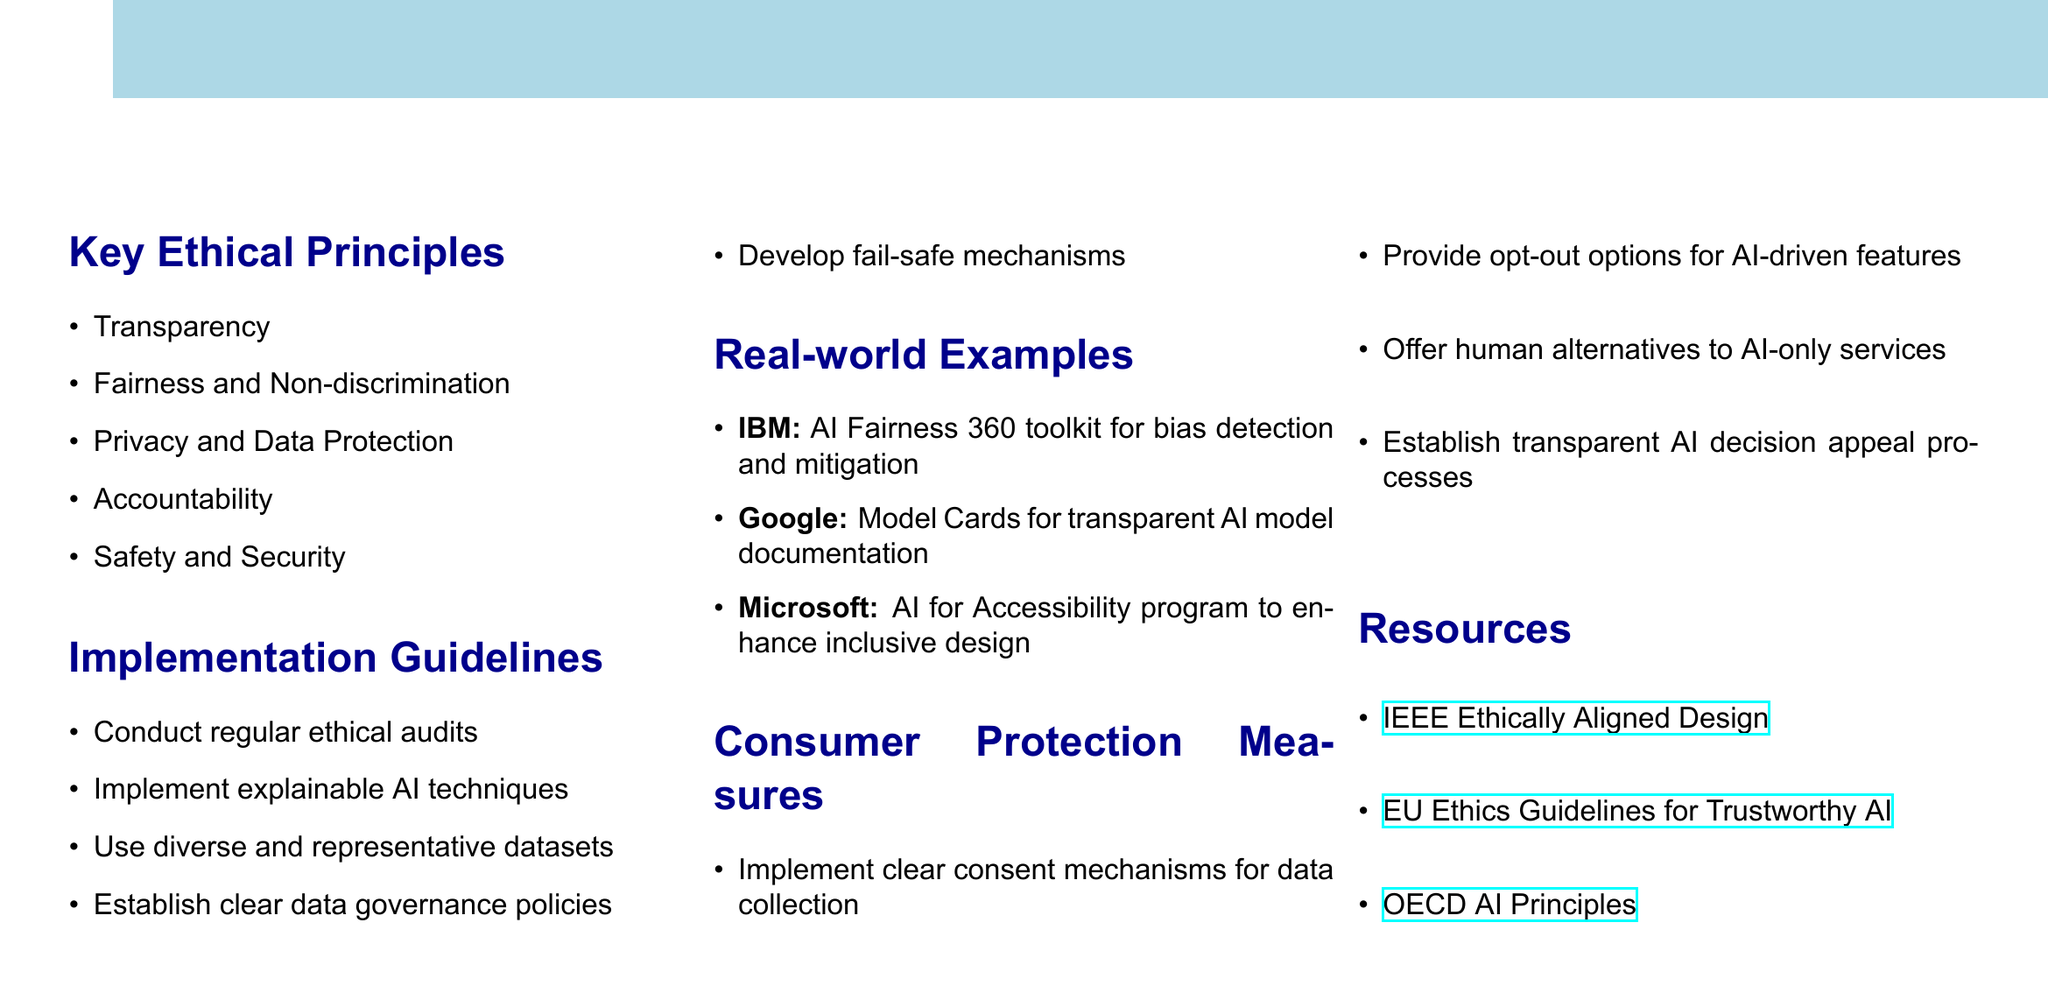What are the key ethical principles? The document lists five key ethical principles in AI ethics, which are mentioned in the "Key Ethical Principles" section.
Answer: Transparency, Fairness and Non-discrimination, Privacy and Data Protection, Accountability, Safety and Security What is the purpose of the AI Fairness 360 toolkit? The document provides a real-world example and mentions that IBM's toolkit is used for bias detection and mitigation under the "Real-world Examples" section.
Answer: Bias detection and mitigation How many consumer protection measures are mentioned? The section titled "Consumer Protection Measures" includes a specific count of measures that promote consumer rights in AI.
Answer: Four What organization provides the "Ethics Guidelines for Trustworthy AI"? The document includes a resource that is attributed to a specificorganization, which is mentioned in the "Resources" section.
Answer: EU What guideline suggests using diverse datasets? The implementation guideline that mentions representing various groups is found in the "Implementation Guidelines" section.
Answer: Use diverse and representative datasets How many real-world examples are provided? The "Real-world Examples" section lists three specific cases that illustrate ethical AI practices.
Answer: Three What should developers implement for data collection? The document specifies a consumer protection measure regarding how developers should handle data collection, which is found in the pertinent section.
Answer: Clear consent mechanisms What is an example of an accessible AI program? The example given under the "Real-world Examples" highlights a specific Microsoft program that aims to improve accessibility in AI design.
Answer: AI for Accessibility What is the main focus of the document? The title suggests that the document addresses specific guidelines and practices related to AI ethics from a particular perspective.
Answer: Consumer Protection 